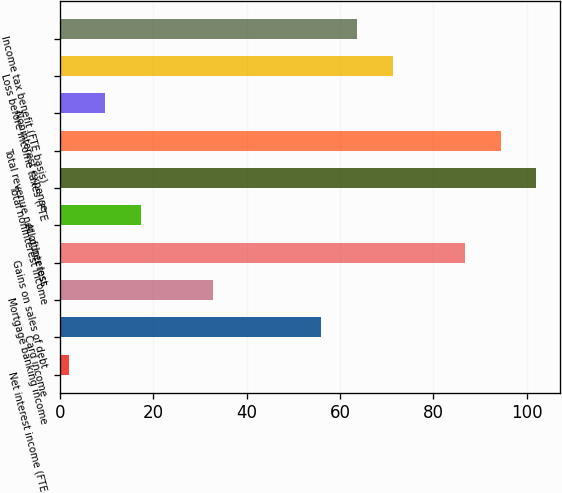<chart> <loc_0><loc_0><loc_500><loc_500><bar_chart><fcel>Net interest income (FTE<fcel>Card income<fcel>Mortgage banking income<fcel>Gains on sales of debt<fcel>All other loss<fcel>Total noninterest income<fcel>Total revenue net of interest<fcel>Noninterest expense<fcel>Loss before income taxes (FTE<fcel>Income tax benefit (FTE basis)<nl><fcel>2<fcel>55.9<fcel>32.8<fcel>86.7<fcel>17.4<fcel>102.1<fcel>94.4<fcel>9.7<fcel>71.3<fcel>63.6<nl></chart> 